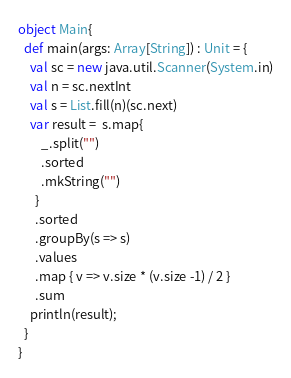Convert code to text. <code><loc_0><loc_0><loc_500><loc_500><_Scala_>object Main{
  def main(args: Array[String]) : Unit = {
    val sc = new java.util.Scanner(System.in)
    val n = sc.nextInt
    val s = List.fill(n)(sc.next)
    var result =  s.map{
        _.split("")
        .sorted
        .mkString("")
      }
      .sorted
      .groupBy(s => s)
      .values
      .map { v => v.size * (v.size -1) / 2 }
      .sum
    println(result);
  }
}
</code> 